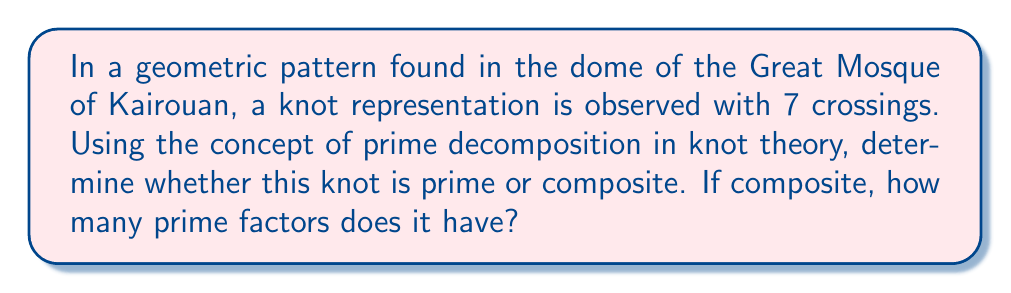Provide a solution to this math problem. To determine if a knot is prime or composite, we need to follow these steps:

1. Recall that a knot is prime if it cannot be decomposed into two non-trivial knots through a connect sum operation.

2. For a knot with 7 crossings, we can refer to the knot table. In knot theory, it is known that all knots with up to 7 crossings are prime, except for the composite knot $3_1 \# 3_1$ (the connect sum of two trefoil knots).

3. The knot $3_1 \# 3_1$ has a crossing number of 6, not 7.

4. Therefore, any knot with exactly 7 crossings must be prime.

5. In the context of Islamic architectural motifs, this primality indicates that the pattern cannot be simplified or broken down into simpler knot components while maintaining its 7-crossing structure.

6. The prime nature of this knot suggests that it represents a fundamental, irreducible element in the geometric design of the mosque's dome.
Answer: Prime knot with 1 prime factor 